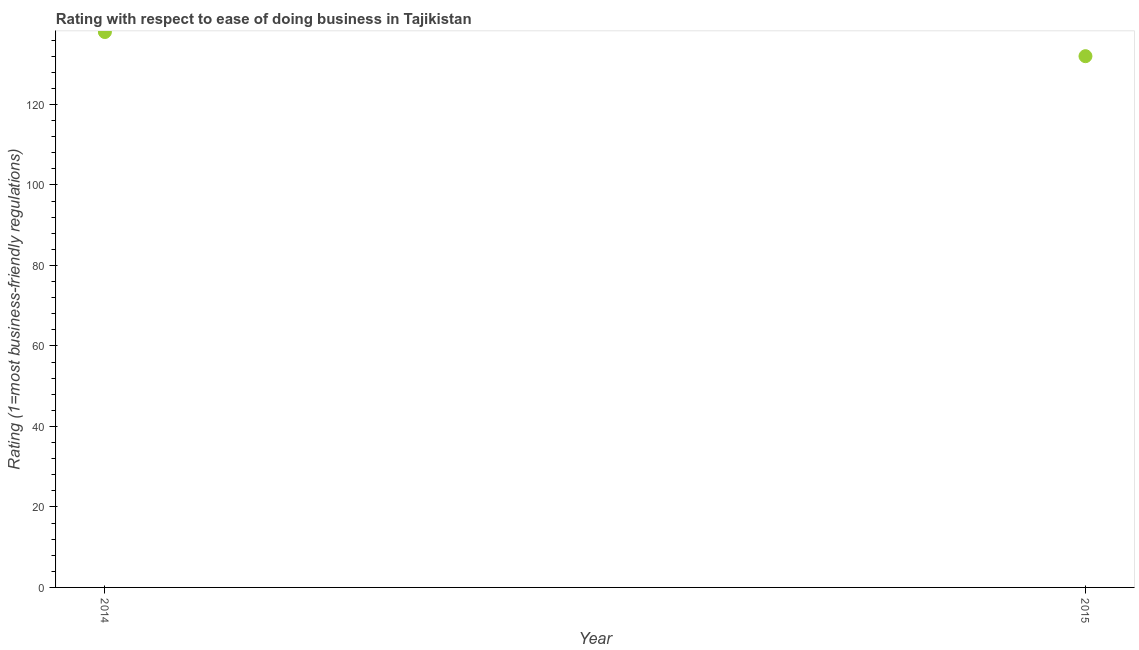What is the ease of doing business index in 2015?
Your answer should be very brief. 132. Across all years, what is the maximum ease of doing business index?
Keep it short and to the point. 138. Across all years, what is the minimum ease of doing business index?
Offer a very short reply. 132. In which year was the ease of doing business index minimum?
Ensure brevity in your answer.  2015. What is the sum of the ease of doing business index?
Your answer should be compact. 270. What is the difference between the ease of doing business index in 2014 and 2015?
Ensure brevity in your answer.  6. What is the average ease of doing business index per year?
Keep it short and to the point. 135. What is the median ease of doing business index?
Offer a very short reply. 135. Do a majority of the years between 2015 and 2014 (inclusive) have ease of doing business index greater than 80 ?
Ensure brevity in your answer.  No. What is the ratio of the ease of doing business index in 2014 to that in 2015?
Make the answer very short. 1.05. Does the ease of doing business index monotonically increase over the years?
Make the answer very short. No. What is the title of the graph?
Ensure brevity in your answer.  Rating with respect to ease of doing business in Tajikistan. What is the label or title of the X-axis?
Offer a very short reply. Year. What is the label or title of the Y-axis?
Keep it short and to the point. Rating (1=most business-friendly regulations). What is the Rating (1=most business-friendly regulations) in 2014?
Keep it short and to the point. 138. What is the Rating (1=most business-friendly regulations) in 2015?
Offer a terse response. 132. What is the ratio of the Rating (1=most business-friendly regulations) in 2014 to that in 2015?
Offer a very short reply. 1.04. 